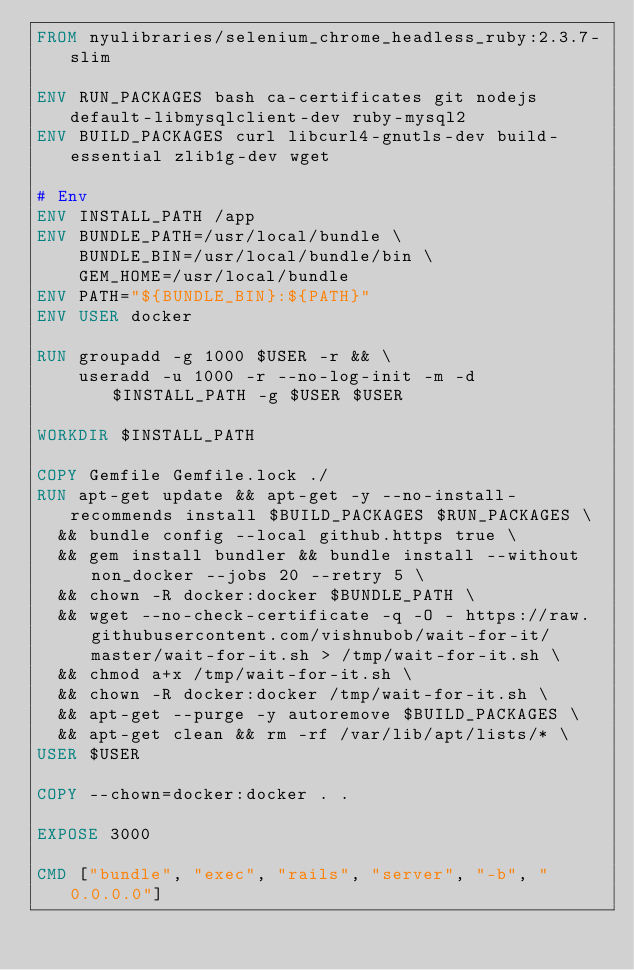<code> <loc_0><loc_0><loc_500><loc_500><_Dockerfile_>FROM nyulibraries/selenium_chrome_headless_ruby:2.3.7-slim

ENV RUN_PACKAGES bash ca-certificates git nodejs default-libmysqlclient-dev ruby-mysql2
ENV BUILD_PACKAGES curl libcurl4-gnutls-dev build-essential zlib1g-dev wget

# Env
ENV INSTALL_PATH /app
ENV BUNDLE_PATH=/usr/local/bundle \
    BUNDLE_BIN=/usr/local/bundle/bin \
    GEM_HOME=/usr/local/bundle
ENV PATH="${BUNDLE_BIN}:${PATH}"
ENV USER docker

RUN groupadd -g 1000 $USER -r && \
    useradd -u 1000 -r --no-log-init -m -d $INSTALL_PATH -g $USER $USER

WORKDIR $INSTALL_PATH

COPY Gemfile Gemfile.lock ./
RUN apt-get update && apt-get -y --no-install-recommends install $BUILD_PACKAGES $RUN_PACKAGES \
  && bundle config --local github.https true \
  && gem install bundler && bundle install --without non_docker --jobs 20 --retry 5 \
  && chown -R docker:docker $BUNDLE_PATH \
  && wget --no-check-certificate -q -O - https://raw.githubusercontent.com/vishnubob/wait-for-it/master/wait-for-it.sh > /tmp/wait-for-it.sh \
  && chmod a+x /tmp/wait-for-it.sh \
  && chown -R docker:docker /tmp/wait-for-it.sh \
  && apt-get --purge -y autoremove $BUILD_PACKAGES \
  && apt-get clean && rm -rf /var/lib/apt/lists/* \
USER $USER

COPY --chown=docker:docker . .

EXPOSE 3000

CMD ["bundle", "exec", "rails", "server", "-b", "0.0.0.0"]
</code> 